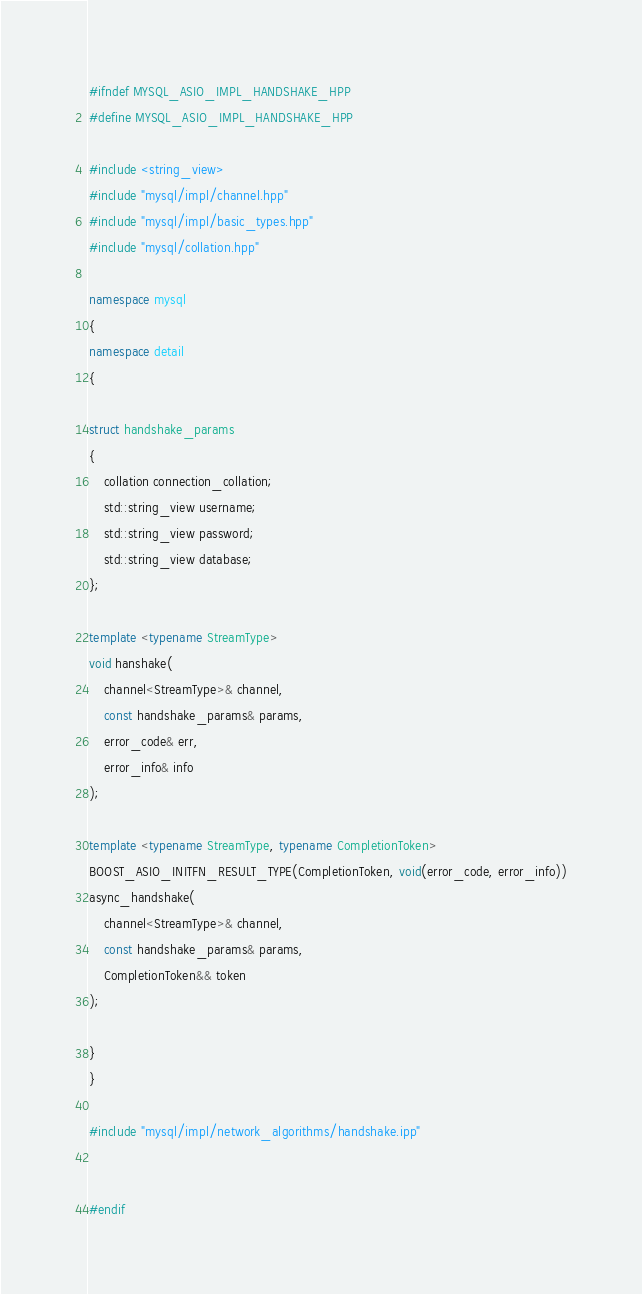Convert code to text. <code><loc_0><loc_0><loc_500><loc_500><_C++_>#ifndef MYSQL_ASIO_IMPL_HANDSHAKE_HPP
#define MYSQL_ASIO_IMPL_HANDSHAKE_HPP

#include <string_view>
#include "mysql/impl/channel.hpp"
#include "mysql/impl/basic_types.hpp"
#include "mysql/collation.hpp"

namespace mysql
{
namespace detail
{

struct handshake_params
{
	collation connection_collation;
	std::string_view username;
	std::string_view password;
	std::string_view database;
};

template <typename StreamType>
void hanshake(
	channel<StreamType>& channel,
	const handshake_params& params,
	error_code& err,
	error_info& info
);

template <typename StreamType, typename CompletionToken>
BOOST_ASIO_INITFN_RESULT_TYPE(CompletionToken, void(error_code, error_info))
async_handshake(
	channel<StreamType>& channel,
	const handshake_params& params,
	CompletionToken&& token
);

}
}

#include "mysql/impl/network_algorithms/handshake.ipp"


#endif
</code> 